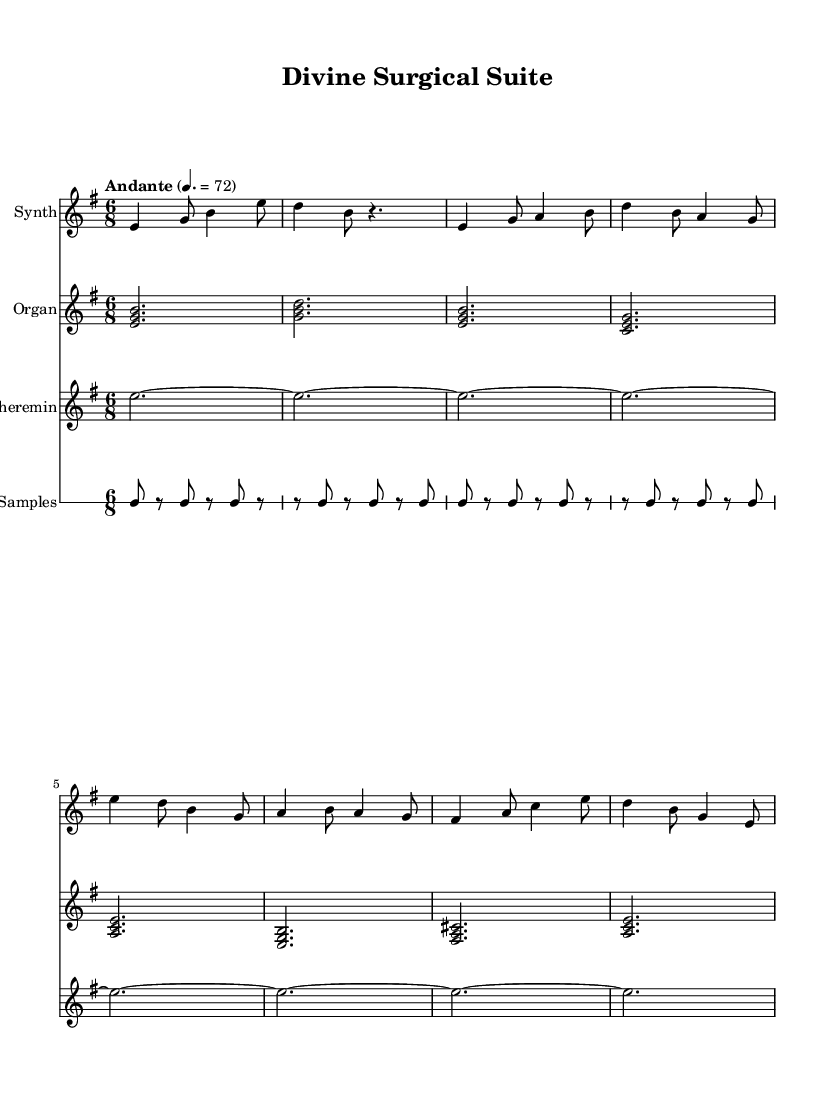What is the key signature of this music? The key signature is E minor, indicated by the presence of one sharp (F#) on the staff.
Answer: E minor What is the time signature of this piece? The time signature is 6/8, which means there are six eighth notes in each measure. This is visually represented at the beginning of the music notation.
Answer: 6/8 What is the tempo marking for this composition? The tempo marking is "Andante," which suggests a moderately slow tempo. The specific BPM (beats per minute) is provided as 72, meaning the piece should be played at this speed.
Answer: Andante, 72 Which instrument plays the continuous eerie background tones? The instrument that plays the continuous eerie background tones is the Theremin, identified by its unique sound which is written as sustained notes throughout the piece.
Answer: Theremin In the Synth part, how many measures are included in the Verse section? There are four measures in the Verse section, as denoted by the musical notation that follows the Intro and precedes the Chorus.
Answer: Four measures How does the rhythmic element in the medical samples relate to the title "Divine Surgical Suite"? The rhythmic elements utilize the sounds of medical instruments, suggesting a fusion of the sacred (Divine) with the clinical (Surgical), creating a unique sense of spirituality intertwined with medical themes.
Answer: Fusion of sacred and clinical themes 